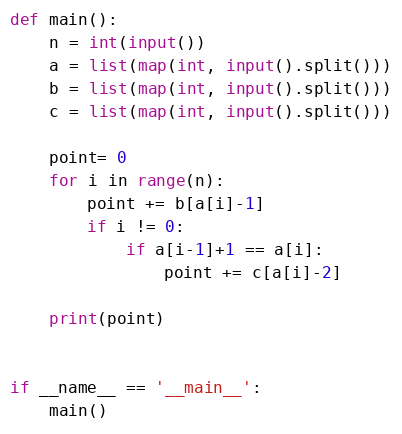Convert code to text. <code><loc_0><loc_0><loc_500><loc_500><_Python_>
def main():
    n = int(input())
    a = list(map(int, input().split()))
    b = list(map(int, input().split()))
    c = list(map(int, input().split()))

    point= 0
    for i in range(n):
        point += b[a[i]-1]
        if i != 0:
            if a[i-1]+1 == a[i]:
                point += c[a[i]-2]
    
    print(point)

    
if __name__ == '__main__':
    main()

</code> 